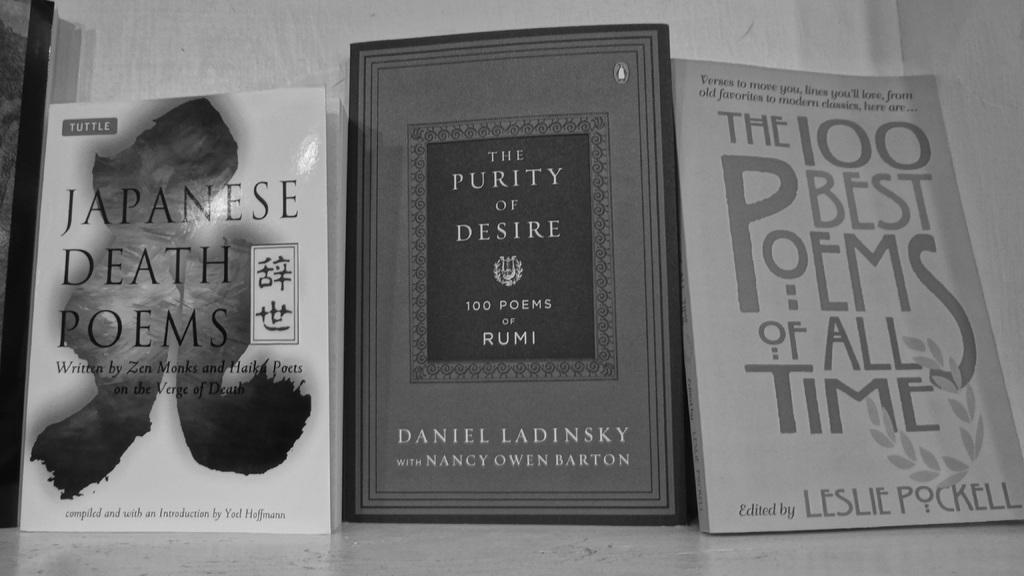<image>
Write a terse but informative summary of the picture. Three books in black and white with titles like JAPANESE DEATH POEMS. 